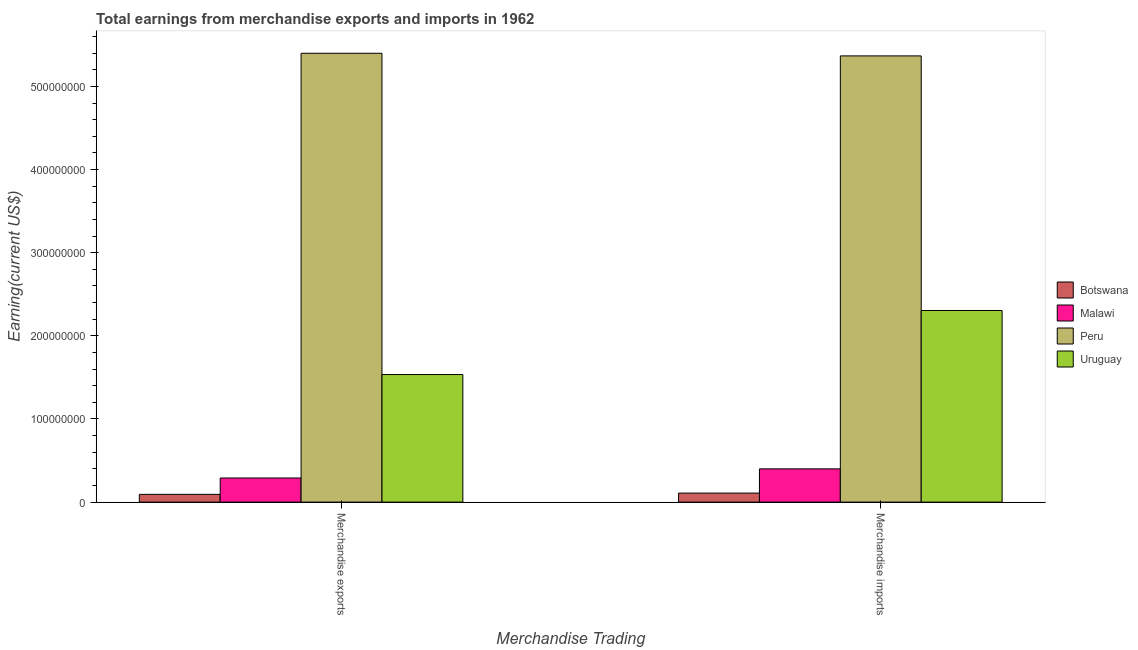How many different coloured bars are there?
Give a very brief answer. 4. Are the number of bars on each tick of the X-axis equal?
Provide a succinct answer. Yes. How many bars are there on the 1st tick from the left?
Your answer should be very brief. 4. What is the label of the 1st group of bars from the left?
Keep it short and to the point. Merchandise exports. What is the earnings from merchandise exports in Uruguay?
Offer a very short reply. 1.53e+08. Across all countries, what is the maximum earnings from merchandise exports?
Your response must be concise. 5.40e+08. Across all countries, what is the minimum earnings from merchandise imports?
Offer a terse response. 1.09e+07. In which country was the earnings from merchandise exports maximum?
Keep it short and to the point. Peru. In which country was the earnings from merchandise exports minimum?
Provide a short and direct response. Botswana. What is the total earnings from merchandise imports in the graph?
Keep it short and to the point. 8.18e+08. What is the difference between the earnings from merchandise imports in Malawi and that in Uruguay?
Ensure brevity in your answer.  -1.90e+08. What is the difference between the earnings from merchandise imports in Malawi and the earnings from merchandise exports in Peru?
Offer a terse response. -5.00e+08. What is the average earnings from merchandise imports per country?
Your answer should be very brief. 2.05e+08. What is the difference between the earnings from merchandise exports and earnings from merchandise imports in Peru?
Provide a succinct answer. 3.17e+06. In how many countries, is the earnings from merchandise exports greater than 520000000 US$?
Make the answer very short. 1. What is the ratio of the earnings from merchandise exports in Botswana to that in Uruguay?
Offer a very short reply. 0.06. Is the earnings from merchandise exports in Uruguay less than that in Malawi?
Your answer should be very brief. No. In how many countries, is the earnings from merchandise imports greater than the average earnings from merchandise imports taken over all countries?
Keep it short and to the point. 2. What does the 4th bar from the left in Merchandise imports represents?
Give a very brief answer. Uruguay. Does the graph contain any zero values?
Offer a very short reply. No. Does the graph contain grids?
Your answer should be very brief. No. Where does the legend appear in the graph?
Your answer should be very brief. Center right. How many legend labels are there?
Your response must be concise. 4. What is the title of the graph?
Make the answer very short. Total earnings from merchandise exports and imports in 1962. What is the label or title of the X-axis?
Give a very brief answer. Merchandise Trading. What is the label or title of the Y-axis?
Your answer should be very brief. Earning(current US$). What is the Earning(current US$) of Botswana in Merchandise exports?
Give a very brief answer. 9.32e+06. What is the Earning(current US$) in Malawi in Merchandise exports?
Provide a short and direct response. 2.90e+07. What is the Earning(current US$) of Peru in Merchandise exports?
Your answer should be compact. 5.40e+08. What is the Earning(current US$) in Uruguay in Merchandise exports?
Offer a very short reply. 1.53e+08. What is the Earning(current US$) of Botswana in Merchandise imports?
Make the answer very short. 1.09e+07. What is the Earning(current US$) in Malawi in Merchandise imports?
Keep it short and to the point. 4.00e+07. What is the Earning(current US$) in Peru in Merchandise imports?
Provide a short and direct response. 5.37e+08. What is the Earning(current US$) in Uruguay in Merchandise imports?
Offer a very short reply. 2.30e+08. Across all Merchandise Trading, what is the maximum Earning(current US$) of Botswana?
Give a very brief answer. 1.09e+07. Across all Merchandise Trading, what is the maximum Earning(current US$) of Malawi?
Offer a terse response. 4.00e+07. Across all Merchandise Trading, what is the maximum Earning(current US$) in Peru?
Offer a terse response. 5.40e+08. Across all Merchandise Trading, what is the maximum Earning(current US$) of Uruguay?
Offer a very short reply. 2.30e+08. Across all Merchandise Trading, what is the minimum Earning(current US$) of Botswana?
Your answer should be compact. 9.32e+06. Across all Merchandise Trading, what is the minimum Earning(current US$) in Malawi?
Provide a succinct answer. 2.90e+07. Across all Merchandise Trading, what is the minimum Earning(current US$) of Peru?
Offer a very short reply. 5.37e+08. Across all Merchandise Trading, what is the minimum Earning(current US$) in Uruguay?
Offer a terse response. 1.53e+08. What is the total Earning(current US$) of Botswana in the graph?
Offer a terse response. 2.02e+07. What is the total Earning(current US$) in Malawi in the graph?
Your response must be concise. 6.90e+07. What is the total Earning(current US$) of Peru in the graph?
Offer a very short reply. 1.08e+09. What is the total Earning(current US$) in Uruguay in the graph?
Provide a succinct answer. 3.84e+08. What is the difference between the Earning(current US$) in Botswana in Merchandise exports and that in Merchandise imports?
Your answer should be compact. -1.56e+06. What is the difference between the Earning(current US$) in Malawi in Merchandise exports and that in Merchandise imports?
Keep it short and to the point. -1.10e+07. What is the difference between the Earning(current US$) in Peru in Merchandise exports and that in Merchandise imports?
Offer a very short reply. 3.17e+06. What is the difference between the Earning(current US$) in Uruguay in Merchandise exports and that in Merchandise imports?
Give a very brief answer. -7.70e+07. What is the difference between the Earning(current US$) of Botswana in Merchandise exports and the Earning(current US$) of Malawi in Merchandise imports?
Ensure brevity in your answer.  -3.07e+07. What is the difference between the Earning(current US$) of Botswana in Merchandise exports and the Earning(current US$) of Peru in Merchandise imports?
Provide a succinct answer. -5.27e+08. What is the difference between the Earning(current US$) in Botswana in Merchandise exports and the Earning(current US$) in Uruguay in Merchandise imports?
Make the answer very short. -2.21e+08. What is the difference between the Earning(current US$) of Malawi in Merchandise exports and the Earning(current US$) of Peru in Merchandise imports?
Your answer should be very brief. -5.08e+08. What is the difference between the Earning(current US$) in Malawi in Merchandise exports and the Earning(current US$) in Uruguay in Merchandise imports?
Provide a short and direct response. -2.01e+08. What is the difference between the Earning(current US$) in Peru in Merchandise exports and the Earning(current US$) in Uruguay in Merchandise imports?
Ensure brevity in your answer.  3.09e+08. What is the average Earning(current US$) in Botswana per Merchandise Trading?
Offer a terse response. 1.01e+07. What is the average Earning(current US$) of Malawi per Merchandise Trading?
Give a very brief answer. 3.45e+07. What is the average Earning(current US$) of Peru per Merchandise Trading?
Your answer should be compact. 5.38e+08. What is the average Earning(current US$) in Uruguay per Merchandise Trading?
Keep it short and to the point. 1.92e+08. What is the difference between the Earning(current US$) in Botswana and Earning(current US$) in Malawi in Merchandise exports?
Provide a short and direct response. -1.97e+07. What is the difference between the Earning(current US$) in Botswana and Earning(current US$) in Peru in Merchandise exports?
Ensure brevity in your answer.  -5.31e+08. What is the difference between the Earning(current US$) in Botswana and Earning(current US$) in Uruguay in Merchandise exports?
Offer a very short reply. -1.44e+08. What is the difference between the Earning(current US$) of Malawi and Earning(current US$) of Peru in Merchandise exports?
Offer a very short reply. -5.11e+08. What is the difference between the Earning(current US$) of Malawi and Earning(current US$) of Uruguay in Merchandise exports?
Provide a short and direct response. -1.24e+08. What is the difference between the Earning(current US$) in Peru and Earning(current US$) in Uruguay in Merchandise exports?
Make the answer very short. 3.86e+08. What is the difference between the Earning(current US$) of Botswana and Earning(current US$) of Malawi in Merchandise imports?
Make the answer very short. -2.91e+07. What is the difference between the Earning(current US$) in Botswana and Earning(current US$) in Peru in Merchandise imports?
Provide a short and direct response. -5.26e+08. What is the difference between the Earning(current US$) of Botswana and Earning(current US$) of Uruguay in Merchandise imports?
Your answer should be very brief. -2.20e+08. What is the difference between the Earning(current US$) of Malawi and Earning(current US$) of Peru in Merchandise imports?
Give a very brief answer. -4.97e+08. What is the difference between the Earning(current US$) of Malawi and Earning(current US$) of Uruguay in Merchandise imports?
Your answer should be compact. -1.90e+08. What is the difference between the Earning(current US$) in Peru and Earning(current US$) in Uruguay in Merchandise imports?
Keep it short and to the point. 3.06e+08. What is the ratio of the Earning(current US$) in Botswana in Merchandise exports to that in Merchandise imports?
Keep it short and to the point. 0.86. What is the ratio of the Earning(current US$) of Malawi in Merchandise exports to that in Merchandise imports?
Your answer should be very brief. 0.72. What is the ratio of the Earning(current US$) in Peru in Merchandise exports to that in Merchandise imports?
Make the answer very short. 1.01. What is the ratio of the Earning(current US$) of Uruguay in Merchandise exports to that in Merchandise imports?
Offer a very short reply. 0.67. What is the difference between the highest and the second highest Earning(current US$) of Botswana?
Your answer should be compact. 1.56e+06. What is the difference between the highest and the second highest Earning(current US$) of Malawi?
Give a very brief answer. 1.10e+07. What is the difference between the highest and the second highest Earning(current US$) of Peru?
Offer a very short reply. 3.17e+06. What is the difference between the highest and the second highest Earning(current US$) of Uruguay?
Your answer should be compact. 7.70e+07. What is the difference between the highest and the lowest Earning(current US$) in Botswana?
Your response must be concise. 1.56e+06. What is the difference between the highest and the lowest Earning(current US$) in Malawi?
Your answer should be compact. 1.10e+07. What is the difference between the highest and the lowest Earning(current US$) in Peru?
Keep it short and to the point. 3.17e+06. What is the difference between the highest and the lowest Earning(current US$) in Uruguay?
Provide a short and direct response. 7.70e+07. 